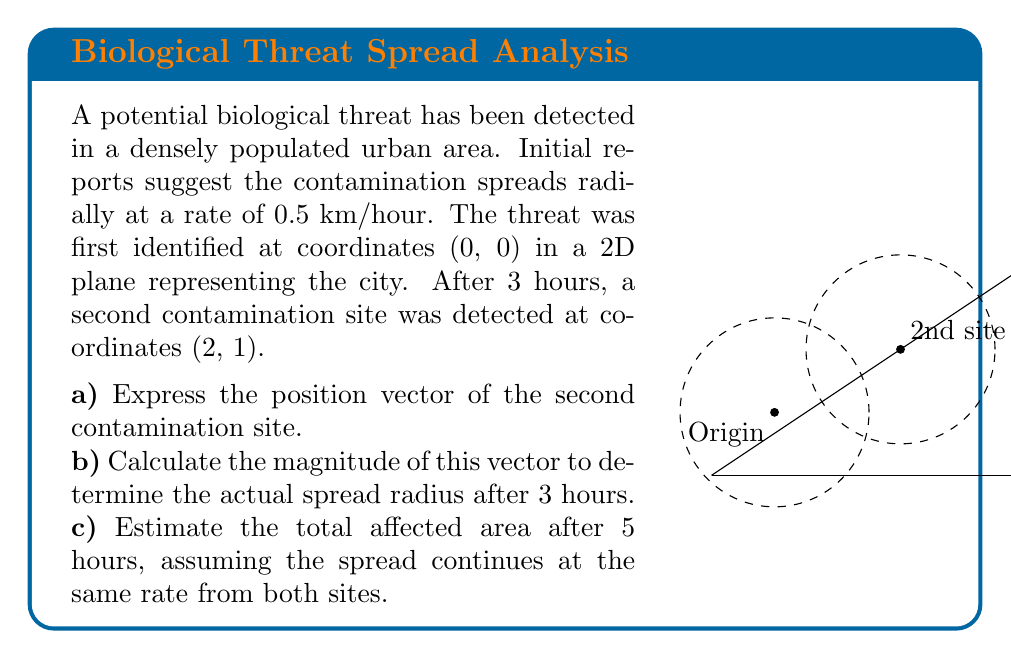Solve this math problem. Let's approach this problem step-by-step:

a) The position vector of the second contamination site:
   Given the coordinates (2, 1), the position vector is:
   $$\vec{r} = 2\hat{i} + \hat{j}$$

b) To calculate the magnitude of this vector:
   $$|\vec{r}| = \sqrt{2^2 + 1^2} = \sqrt{5} \approx 2.24 \text{ km}$$
   
   This represents the actual spread radius after 3 hours. We can verify if this aligns with the given spread rate:
   $$\text{Spread rate} = \frac{2.24 \text{ km}}{3 \text{ hours}} \approx 0.75 \text{ km/hour}$$
   
   This is higher than the initial estimate of 0.5 km/hour, suggesting potential variability in spread rate or external factors influencing the spread.

c) To estimate the total affected area after 5 hours:
   - For each site, the radius after 5 hours would be: $5 \text{ hours} \times 0.5 \text{ km/hour} = 2.5 \text{ km}$
   - The area of each circular region: $A = \pi r^2 = \pi (2.5)^2 \approx 19.63 \text{ km}^2$
   - Total area of two circles: $2 \times 19.63 = 39.26 \text{ km}^2$
   
   However, these circles overlap. To account for this:
   - Distance between centers: $\sqrt{5} \approx 2.24 \text{ km}$
   - Overlap occurs as $2.24 < 2.5 + 2.5$
   - We can use the formula for the area of intersection of two circles:
     $$A = 2r^2 \arccos(\frac{d}{2r}) - d\sqrt{r^2 - \frac{d^2}{4}}$$
     where $r = 2.5$ and $d = 2.24$
   
   Calculating this (which involves complex trigonometry) gives an overlap area of approximately 7.63 km².

   Therefore, the total affected area is:
   $$39.26 \text{ km}^2 - 7.63 \text{ km}^2 = 31.63 \text{ km}^2$$
Answer: a) $\vec{r} = 2\hat{i} + \hat{j}$
b) $2.24 \text{ km}$
c) $31.63 \text{ km}^2$ 